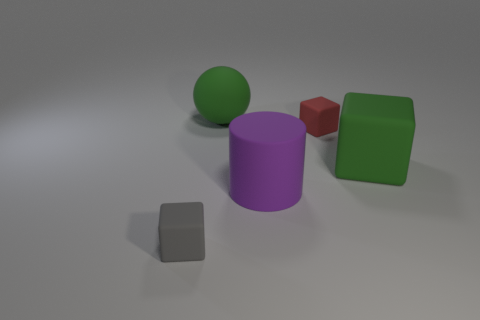Subtract all brown cubes. Subtract all yellow cylinders. How many cubes are left? 3 Add 1 large purple things. How many objects exist? 6 Subtract all spheres. How many objects are left? 4 Subtract 0 blue spheres. How many objects are left? 5 Subtract all blue cubes. Subtract all tiny red blocks. How many objects are left? 4 Add 1 balls. How many balls are left? 2 Add 4 big cyan cubes. How many big cyan cubes exist? 4 